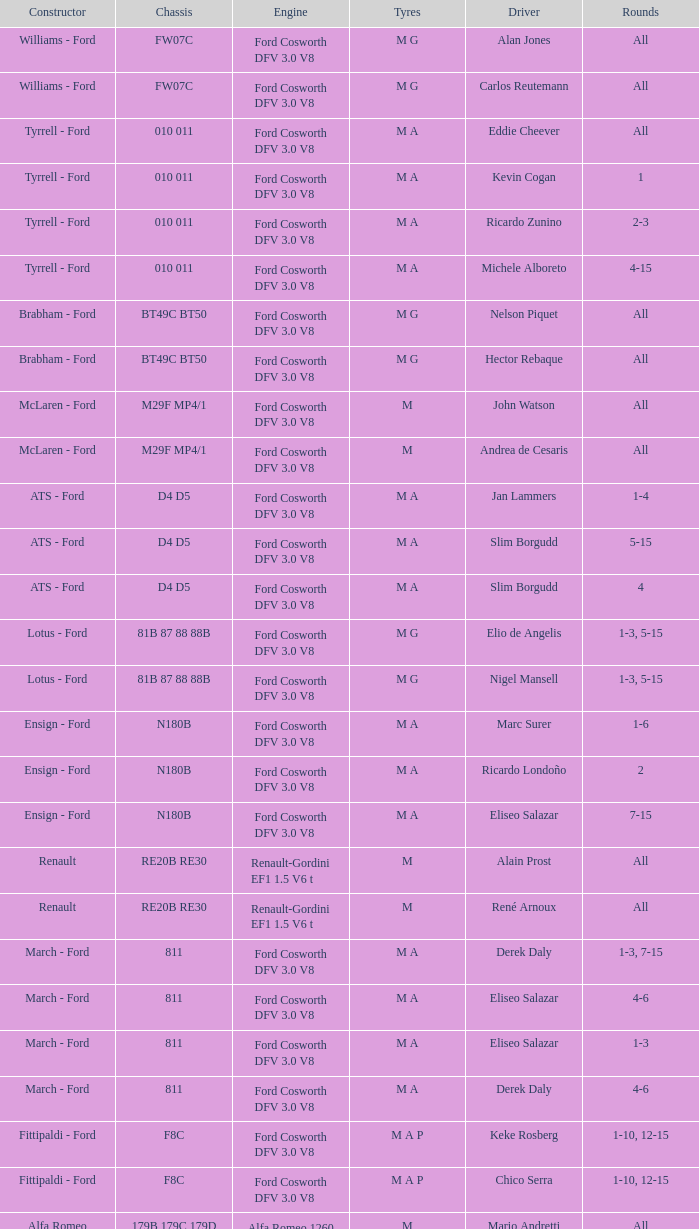Who built the car with a tg181 chassis that derek warwick drove in a race? Toleman - Hart. 